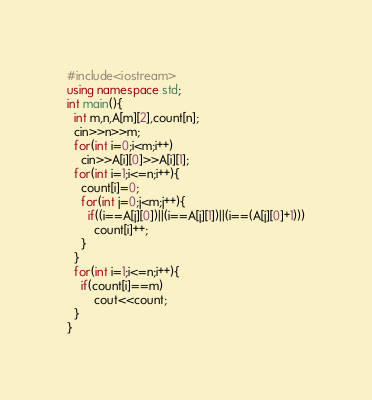<code> <loc_0><loc_0><loc_500><loc_500><_C++_>#include<iostream>
using namespace std;
int main(){
  int m,n,A[m][2],count[n];
  cin>>n>>m;
  for(int i=0;i<m;i++)
    cin>>A[i][0]>>A[i][1];
  for(int i=1;i<=n;i++){
    count[i]=0;
    for(int j=0;j<m;j++){
      if((i==A[j][0])||(i==A[j][1])||(i==(A[j][0]+1)))
        count[i]++;
    }
  }
  for(int i=1;i<=n;i++){
    if(count[i]==m)
  		cout<<count;
  }
}
</code> 